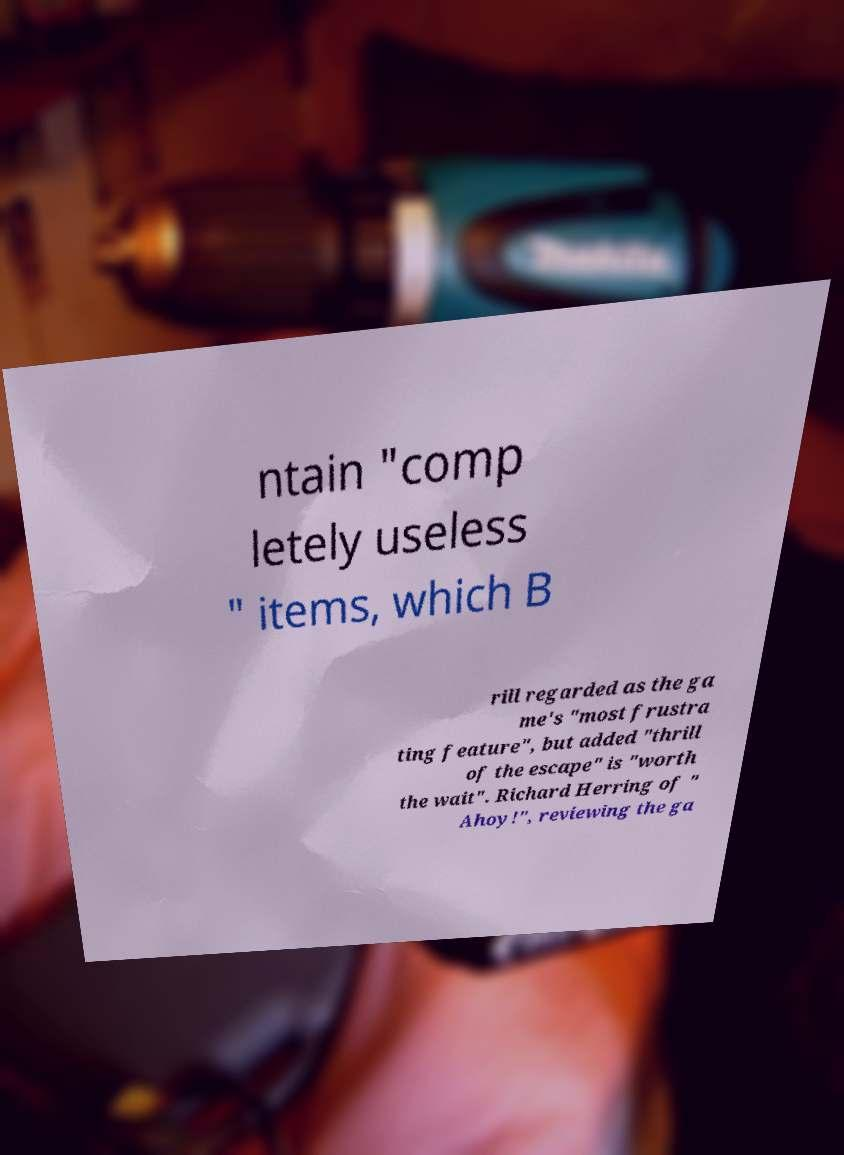Could you extract and type out the text from this image? ntain "comp letely useless " items, which B rill regarded as the ga me's "most frustra ting feature", but added "thrill of the escape" is "worth the wait". Richard Herring of " Ahoy!", reviewing the ga 